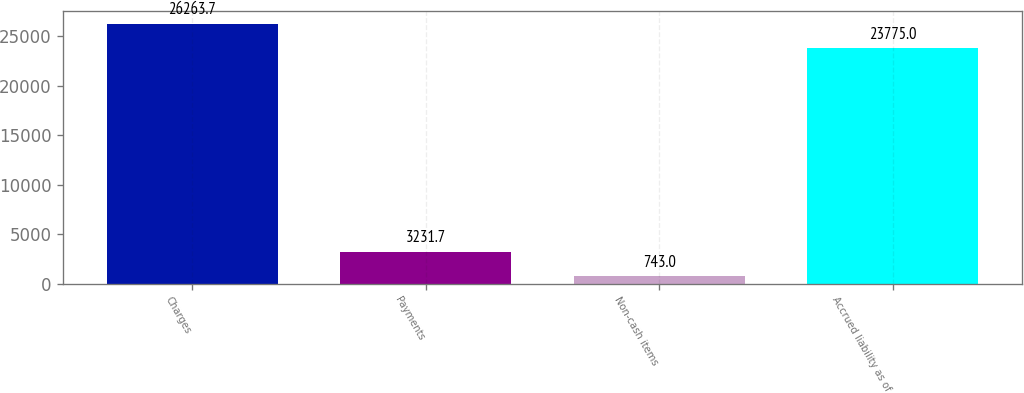Convert chart to OTSL. <chart><loc_0><loc_0><loc_500><loc_500><bar_chart><fcel>Charges<fcel>Payments<fcel>Non-cash items<fcel>Accrued liability as of<nl><fcel>26263.7<fcel>3231.7<fcel>743<fcel>23775<nl></chart> 